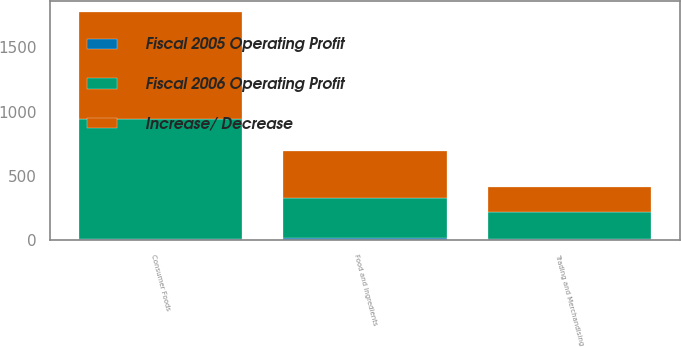Convert chart. <chart><loc_0><loc_0><loc_500><loc_500><stacked_bar_chart><ecel><fcel>Consumer Foods<fcel>Food and Ingredients<fcel>Trading and Merchandising<nl><fcel>Increase/ Decrease<fcel>828<fcel>364<fcel>189<nl><fcel>Fiscal 2006 Operating Profit<fcel>934<fcel>310<fcel>212<nl><fcel>Fiscal 2005 Operating Profit<fcel>11<fcel>17<fcel>11<nl></chart> 